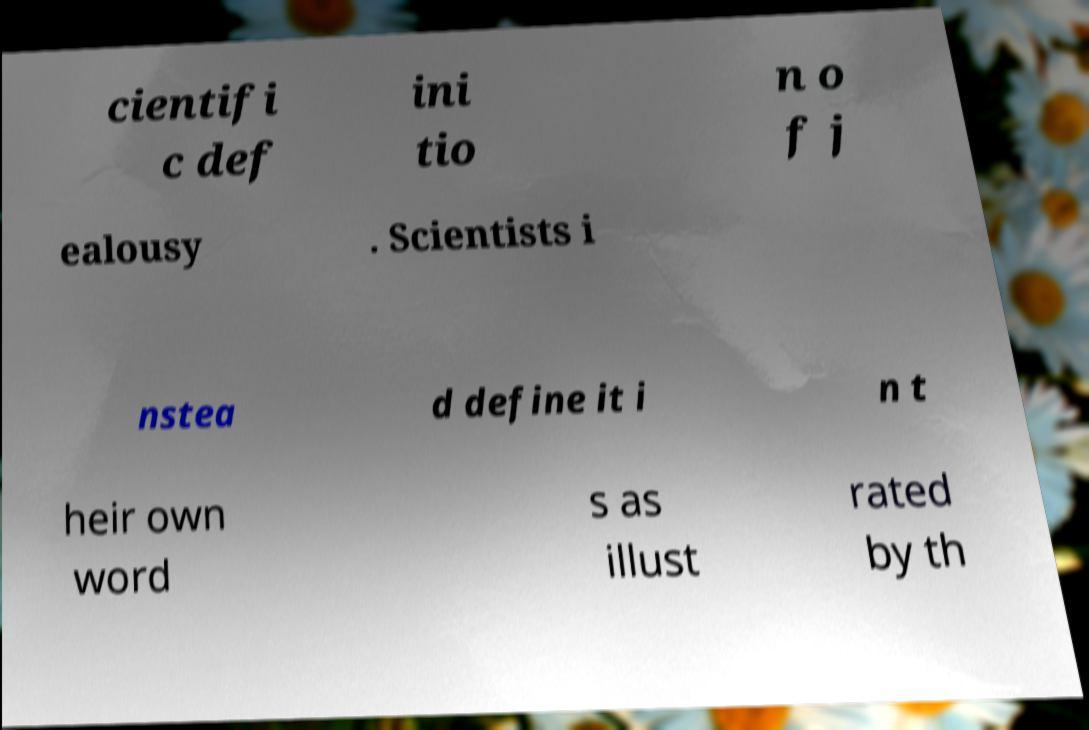Could you extract and type out the text from this image? cientifi c def ini tio n o f j ealousy . Scientists i nstea d define it i n t heir own word s as illust rated by th 